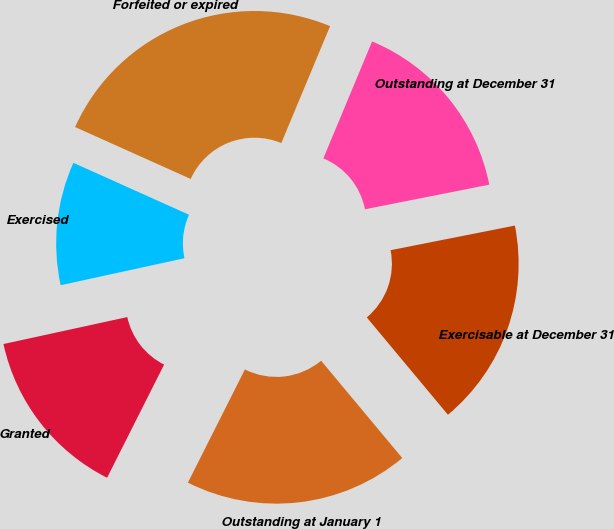Convert chart to OTSL. <chart><loc_0><loc_0><loc_500><loc_500><pie_chart><fcel>Outstanding at January 1<fcel>Granted<fcel>Exercised<fcel>Forfeited or expired<fcel>Outstanding at December 31<fcel>Exercisable at December 31<nl><fcel>18.49%<fcel>14.16%<fcel>10.13%<fcel>24.57%<fcel>15.6%<fcel>17.05%<nl></chart> 